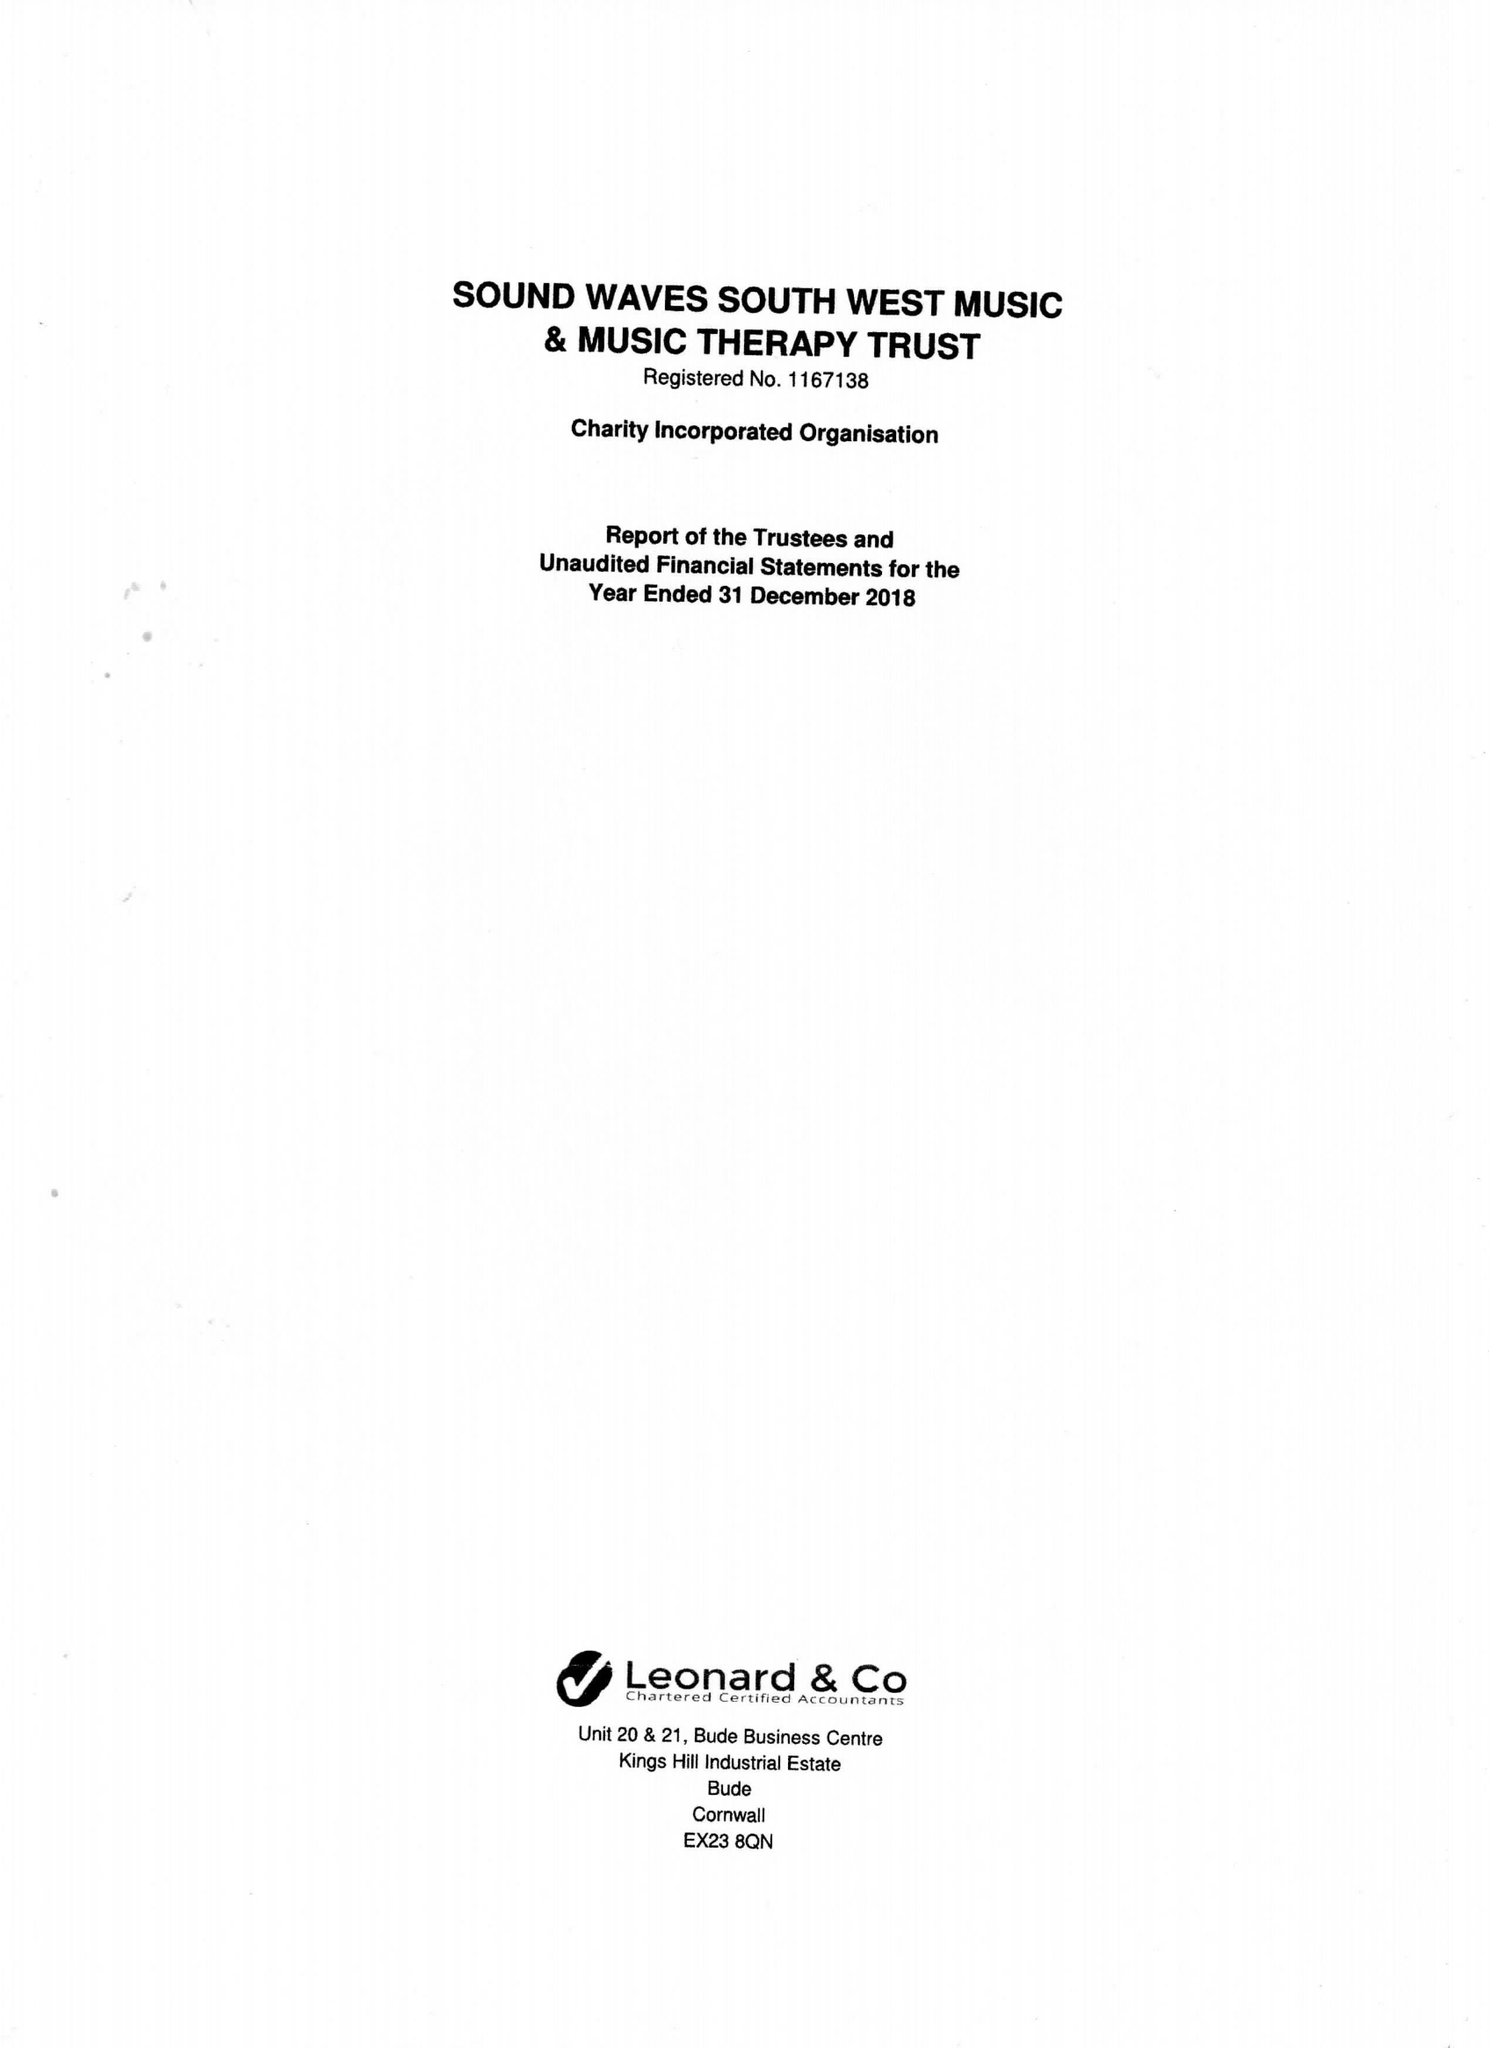What is the value for the charity_number?
Answer the question using a single word or phrase. 1167138 